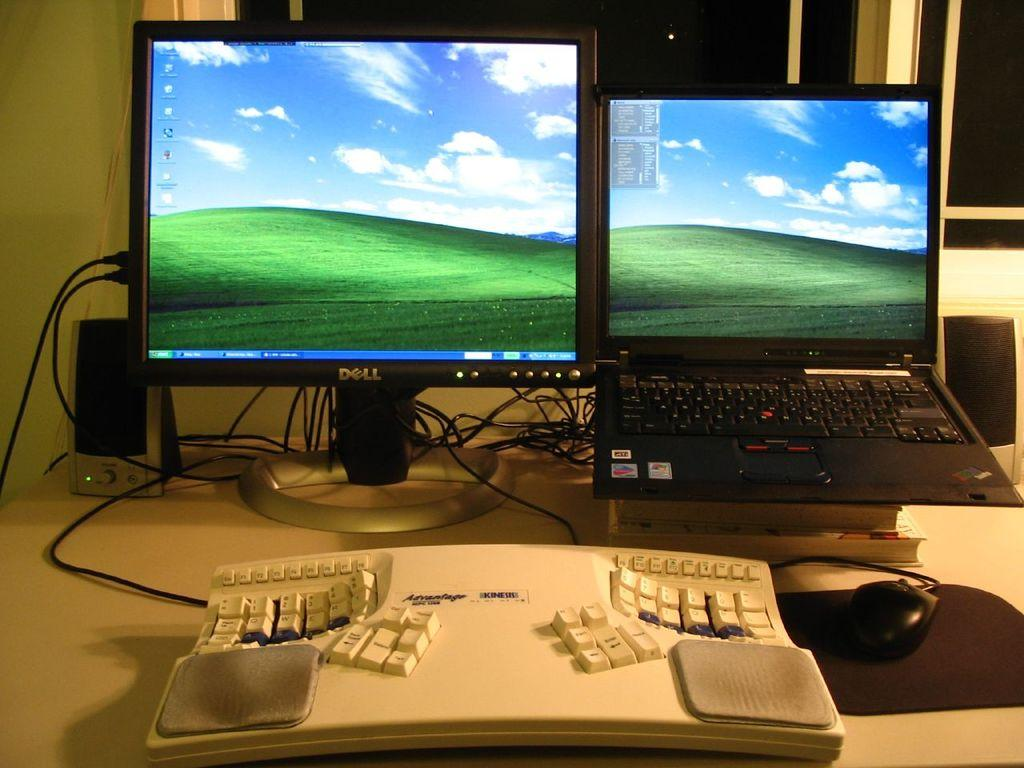<image>
Present a compact description of the photo's key features. laptop and dell monitor, both have windows xp wallpaper 